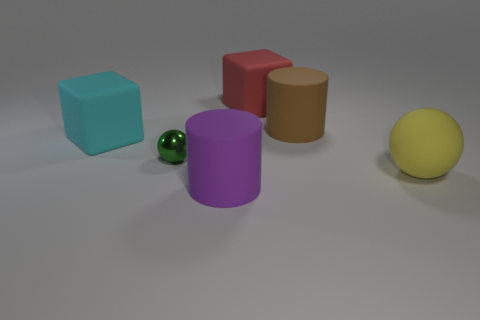Can you tell me the colors of the objects starting from the leftmost one? Sure, from left to right, the colors of the objects begin with a teal cube, followed by a green sphere, a purple cylinder, a brown cube, and finally a yellow sphere on the far right. 